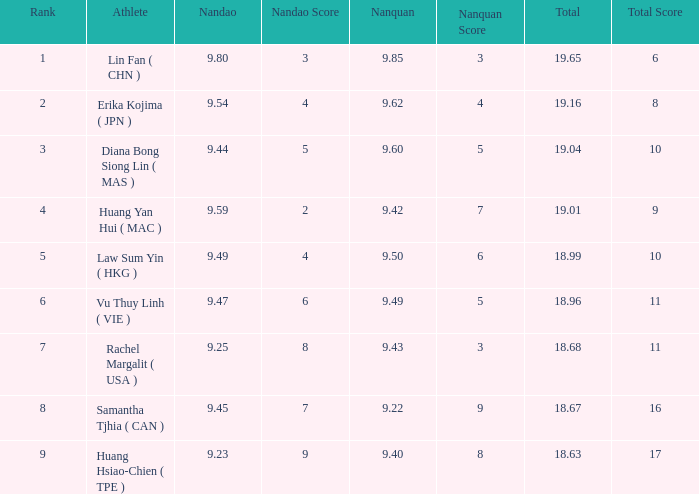Which Nanquan has a Nandao smaller than 9.44, and a Rank smaller than 9, and a Total larger than 18.68? None. 